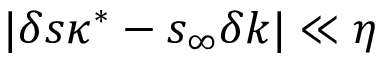Convert formula to latex. <formula><loc_0><loc_0><loc_500><loc_500>| \delta s \kappa ^ { * } - s _ { \infty } \delta k | \ll \eta</formula> 